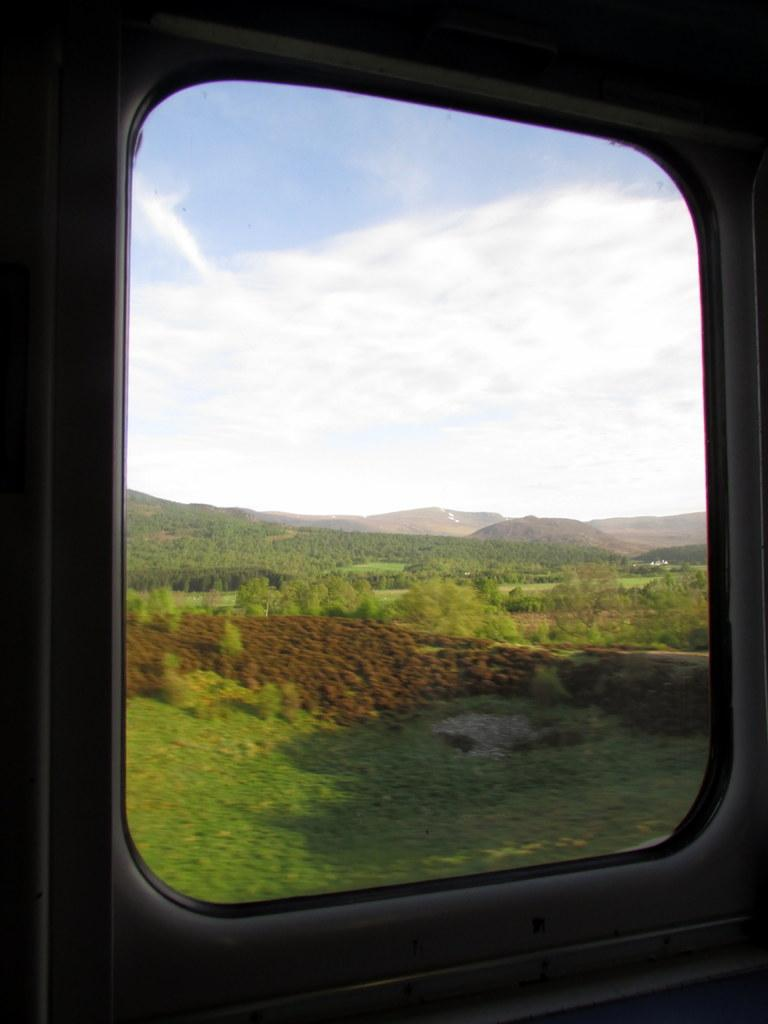What type of vegetation can be seen in the image? There are trees visible in the image. What else is visible in the image besides the trees? The sky is visible in the image. Can you describe any man-made structures in the image? There is a glass window visible in the image. How many tomatoes are hanging from the trees in the image? There are no tomatoes visible in the image; only trees are present. What type of flesh can be seen in the image? There is no flesh visible in the image; it features trees and a sky. 